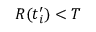<formula> <loc_0><loc_0><loc_500><loc_500>R ( t _ { i } ^ { \prime } ) < T</formula> 